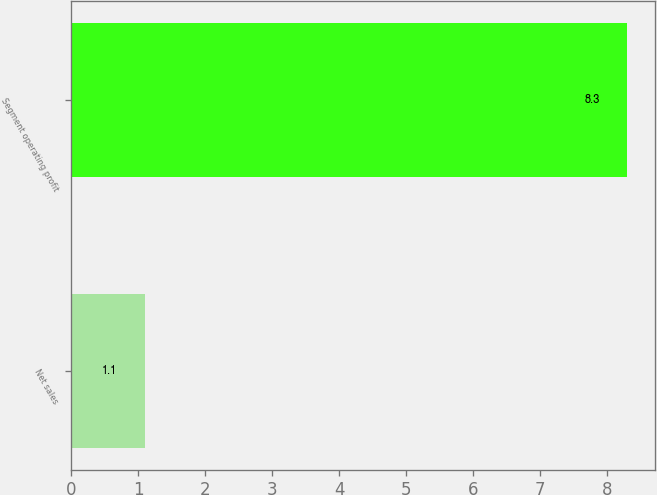Convert chart to OTSL. <chart><loc_0><loc_0><loc_500><loc_500><bar_chart><fcel>Net sales<fcel>Segment operating profit<nl><fcel>1.1<fcel>8.3<nl></chart> 